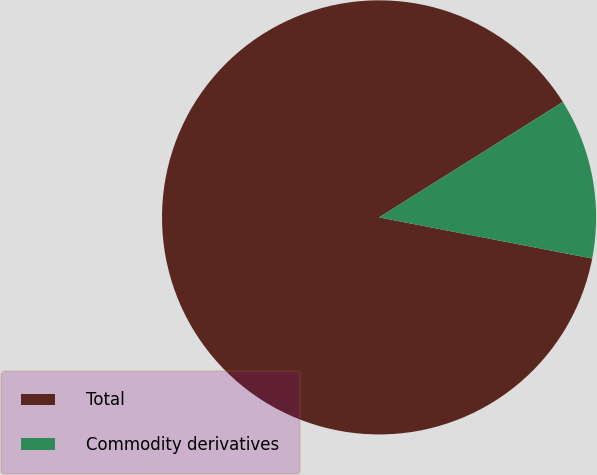<chart> <loc_0><loc_0><loc_500><loc_500><pie_chart><fcel>Total<fcel>Commodity derivatives<nl><fcel>88.04%<fcel>11.96%<nl></chart> 